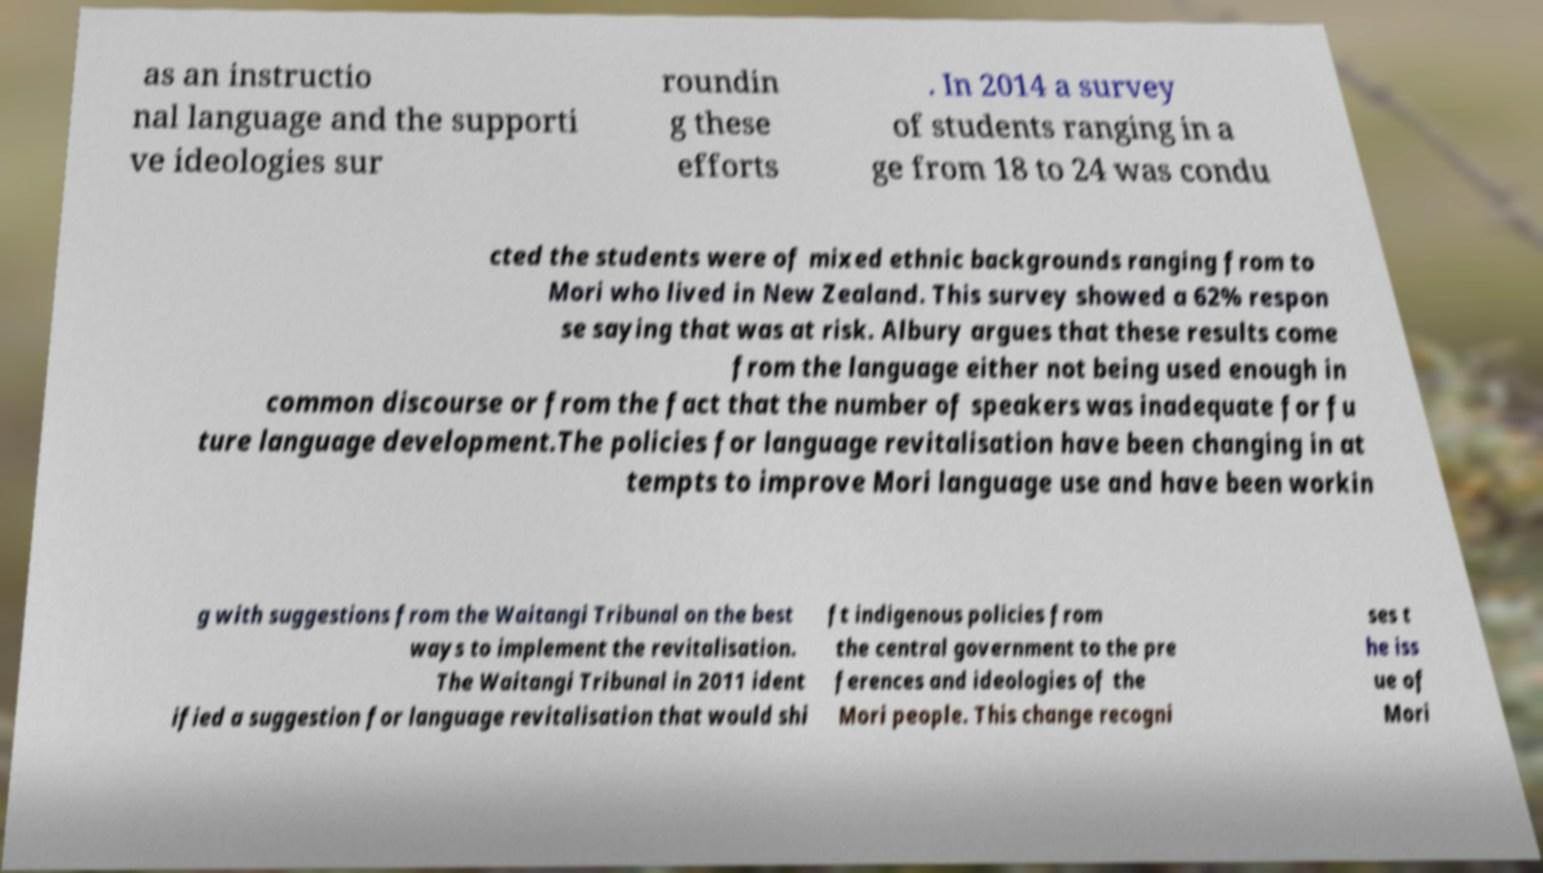I need the written content from this picture converted into text. Can you do that? as an instructio nal language and the supporti ve ideologies sur roundin g these efforts . In 2014 a survey of students ranging in a ge from 18 to 24 was condu cted the students were of mixed ethnic backgrounds ranging from to Mori who lived in New Zealand. This survey showed a 62% respon se saying that was at risk. Albury argues that these results come from the language either not being used enough in common discourse or from the fact that the number of speakers was inadequate for fu ture language development.The policies for language revitalisation have been changing in at tempts to improve Mori language use and have been workin g with suggestions from the Waitangi Tribunal on the best ways to implement the revitalisation. The Waitangi Tribunal in 2011 ident ified a suggestion for language revitalisation that would shi ft indigenous policies from the central government to the pre ferences and ideologies of the Mori people. This change recogni ses t he iss ue of Mori 